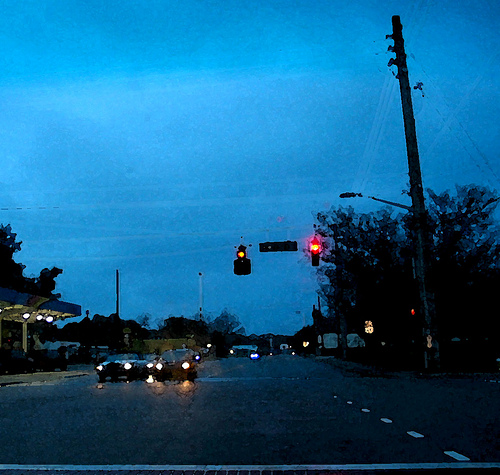Describe the atmosphere and possible time of day depicted in the image. The atmosphere in the image suggests a calm, possibly chilly dusk or early evening. The sky is a deep, muted blue, indicating that the sun has set or is about to set. This time of day typically sees reduced visibility, which is why the streetlights and traffic lights are prominently lit. The overall mood is tranquil, with an understated hustle as a few cars make their way through the intersection. What details can you see about the cars in the image? In the image, there are a few cars visible, all with their headlights turned on. This suggests that natural light is low, further supporting the idea of it being dusk or early evening. The cars are likely either waiting at or approaching the intersection. Although specific models and colors of the cars are difficult to discern due to the lighting, their illuminated headlights create small pools of light on the road, adding to the scene's atmospheric detail. 